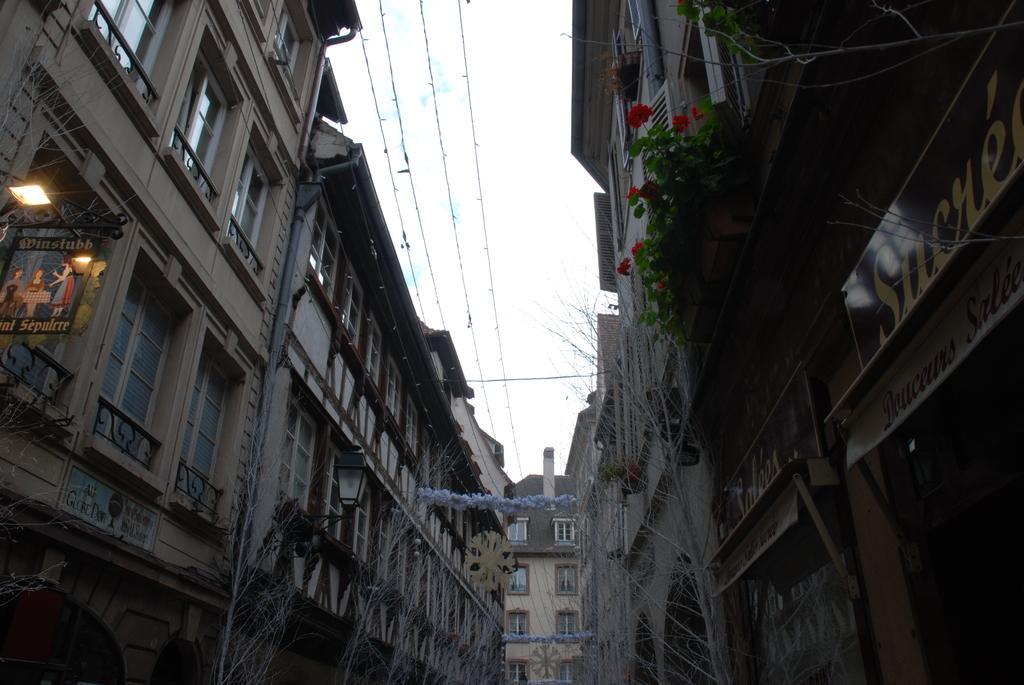Please provide a concise description of this image. In this image I can see building , on the building I can see flowers and plants and hoarding board, on the hoarding board there is a light and in the middle there are power line cables and the sky. 